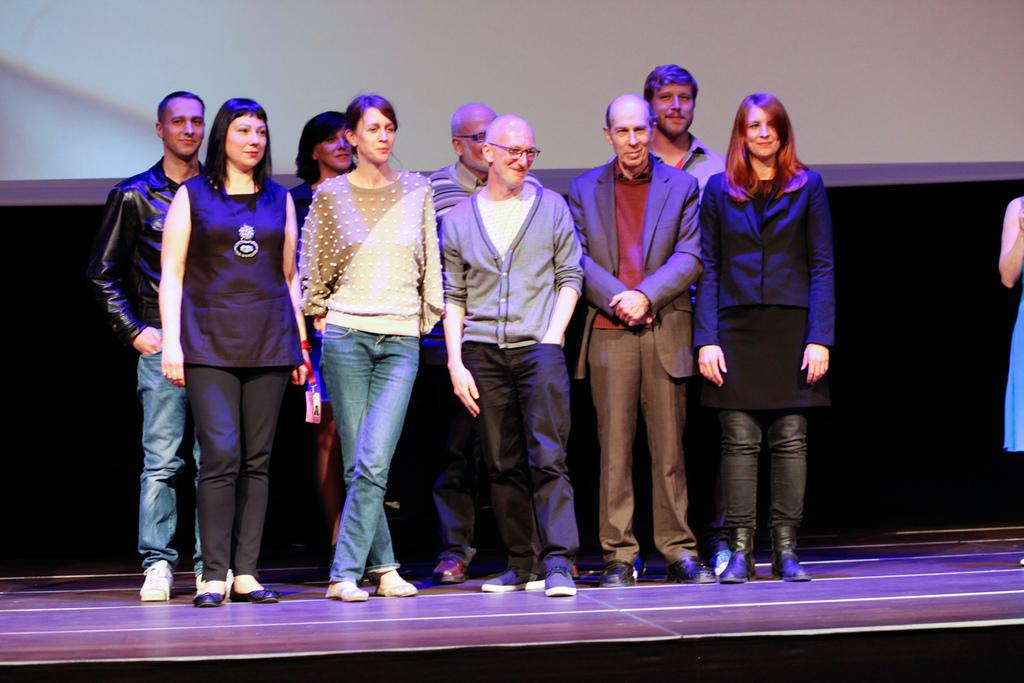What is happening in the foreground of the image? There is a group of people in the foreground of the image. Where are the people located? The group of people is standing on a stage. What can be seen in the background of the image? There is a wall visible in the background of the image, and there are objects present as well. What can be inferred about the setting of the image? The image is likely taken on a stage, given the presence of the group of people and the wall in the background. What type of wax is being used to order the fight in the image? There is no wax, order, or fight present in the image. The image features a group of people standing on a stage with a wall and objects in the background. 